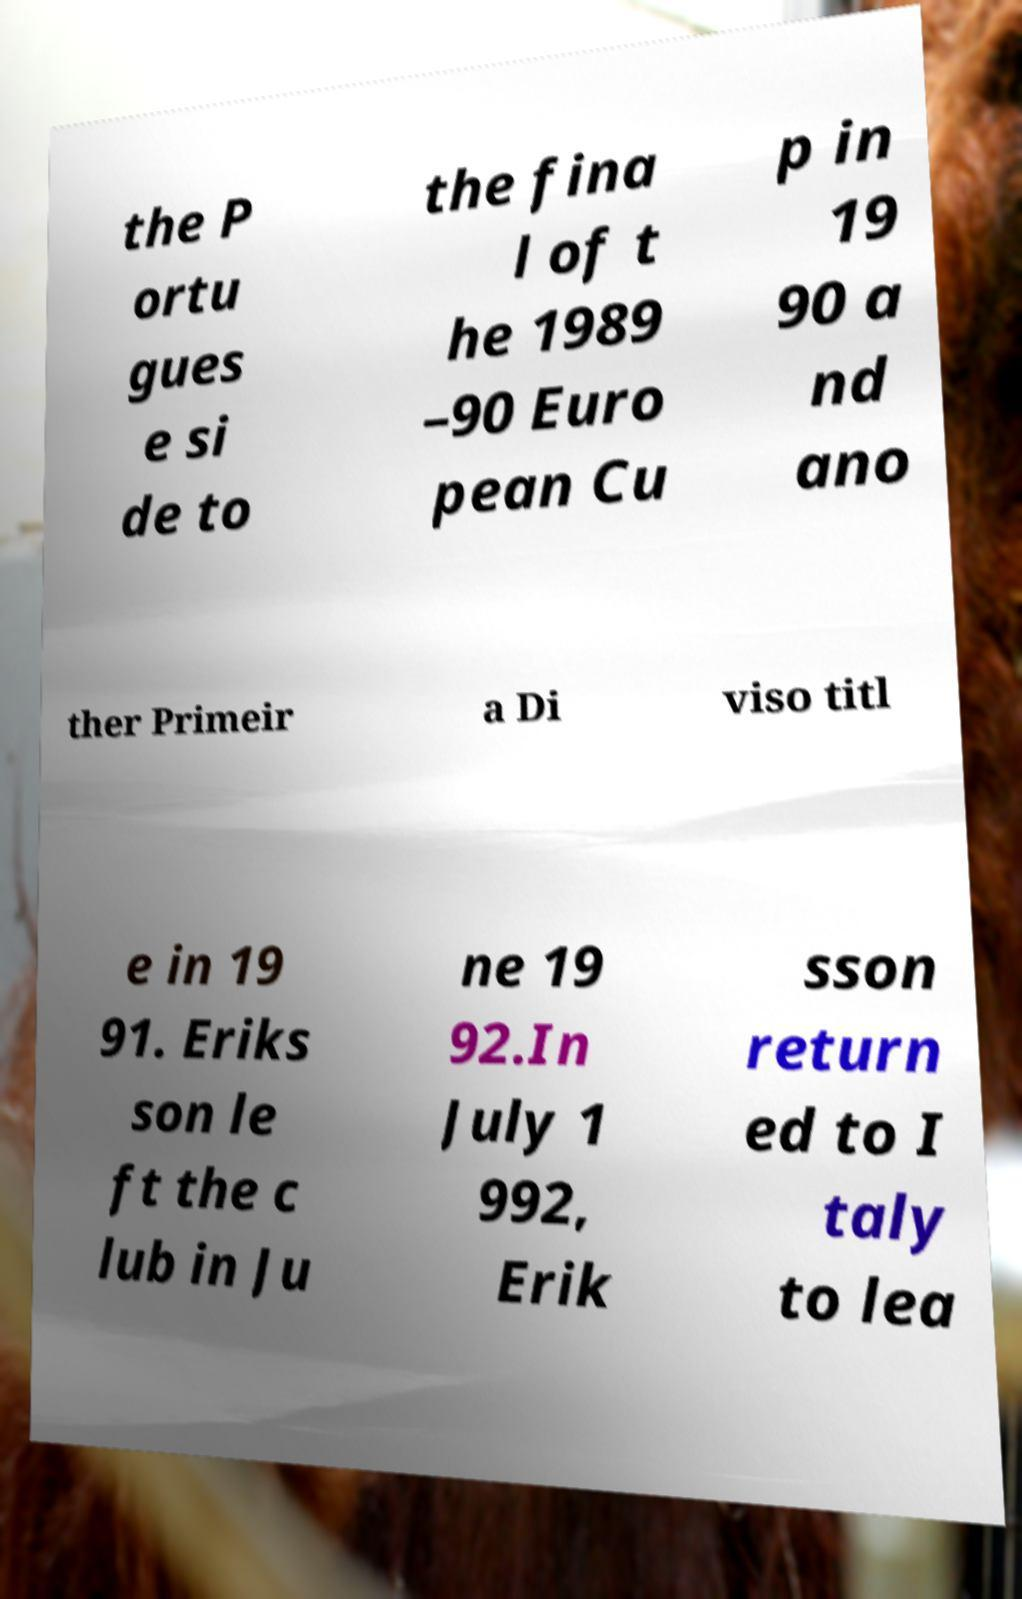There's text embedded in this image that I need extracted. Can you transcribe it verbatim? the P ortu gues e si de to the fina l of t he 1989 –90 Euro pean Cu p in 19 90 a nd ano ther Primeir a Di viso titl e in 19 91. Eriks son le ft the c lub in Ju ne 19 92.In July 1 992, Erik sson return ed to I taly to lea 